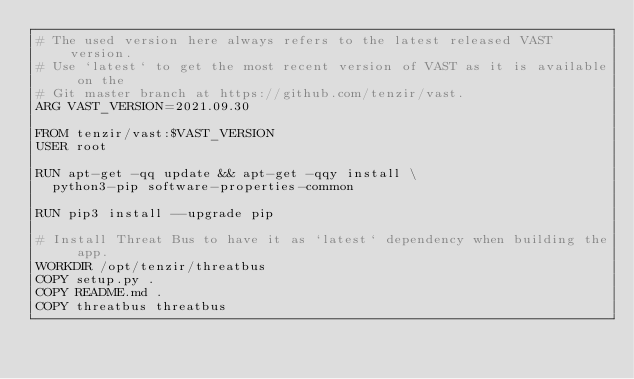<code> <loc_0><loc_0><loc_500><loc_500><_Dockerfile_># The used version here always refers to the latest released VAST version.
# Use `latest` to get the most recent version of VAST as it is available on the
# Git master branch at https://github.com/tenzir/vast.
ARG VAST_VERSION=2021.09.30

FROM tenzir/vast:$VAST_VERSION
USER root

RUN apt-get -qq update && apt-get -qqy install \
  python3-pip software-properties-common

RUN pip3 install --upgrade pip

# Install Threat Bus to have it as `latest` dependency when building the app.
WORKDIR /opt/tenzir/threatbus
COPY setup.py .
COPY README.md .
COPY threatbus threatbus</code> 